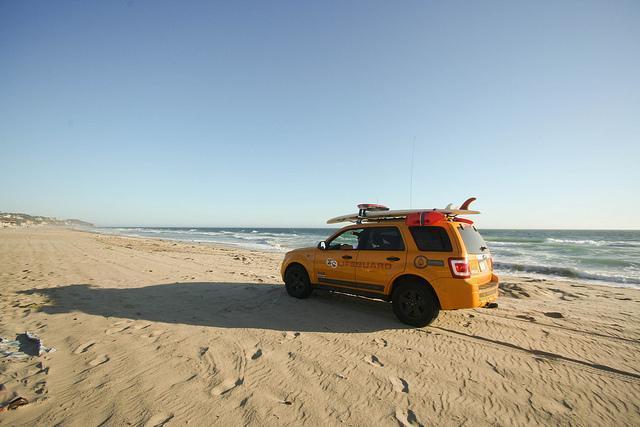How many cars are there?
Give a very brief answer. 1. 